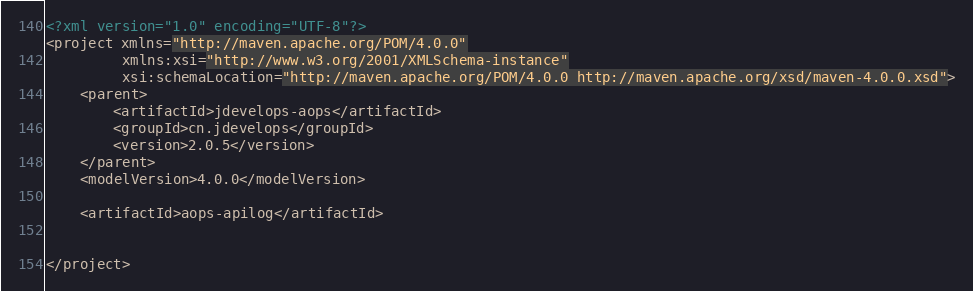Convert code to text. <code><loc_0><loc_0><loc_500><loc_500><_XML_><?xml version="1.0" encoding="UTF-8"?>
<project xmlns="http://maven.apache.org/POM/4.0.0"
         xmlns:xsi="http://www.w3.org/2001/XMLSchema-instance"
         xsi:schemaLocation="http://maven.apache.org/POM/4.0.0 http://maven.apache.org/xsd/maven-4.0.0.xsd">
    <parent>
        <artifactId>jdevelops-aops</artifactId>
        <groupId>cn.jdevelops</groupId>
        <version>2.0.5</version>
    </parent>
    <modelVersion>4.0.0</modelVersion>

    <artifactId>aops-apilog</artifactId>


</project></code> 